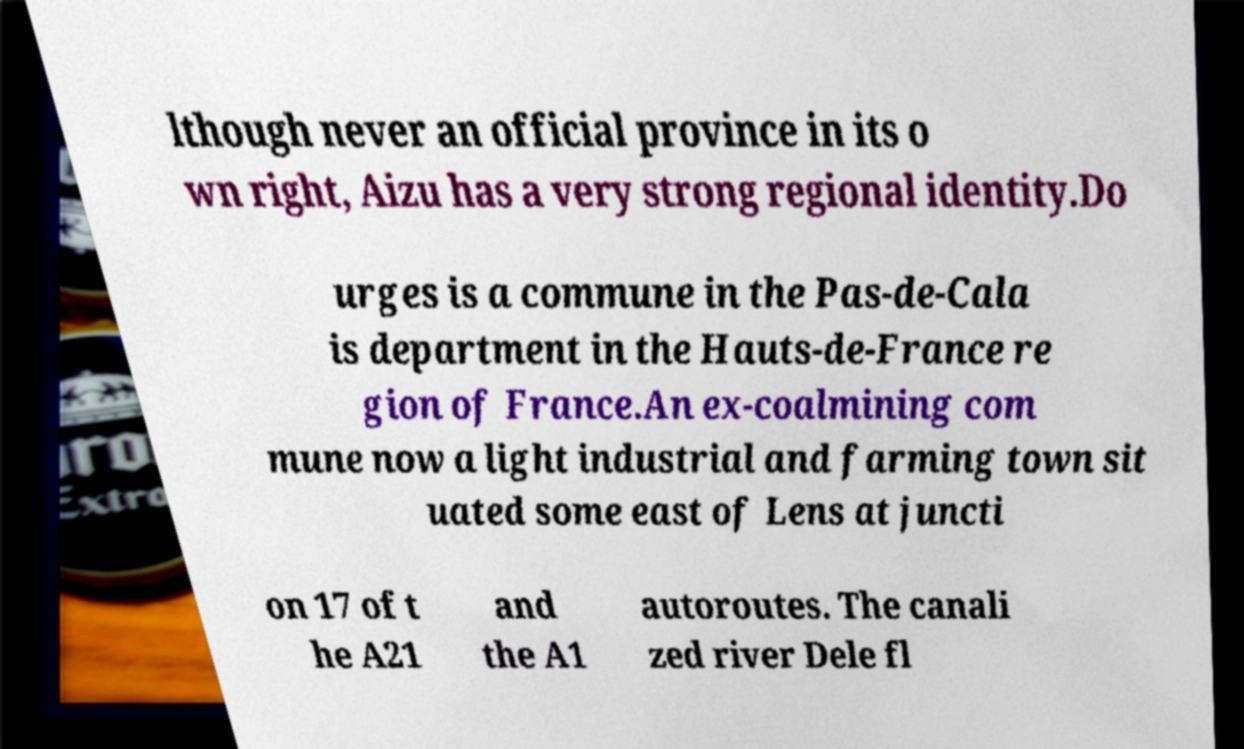Could you assist in decoding the text presented in this image and type it out clearly? lthough never an official province in its o wn right, Aizu has a very strong regional identity.Do urges is a commune in the Pas-de-Cala is department in the Hauts-de-France re gion of France.An ex-coalmining com mune now a light industrial and farming town sit uated some east of Lens at juncti on 17 of t he A21 and the A1 autoroutes. The canali zed river Dele fl 